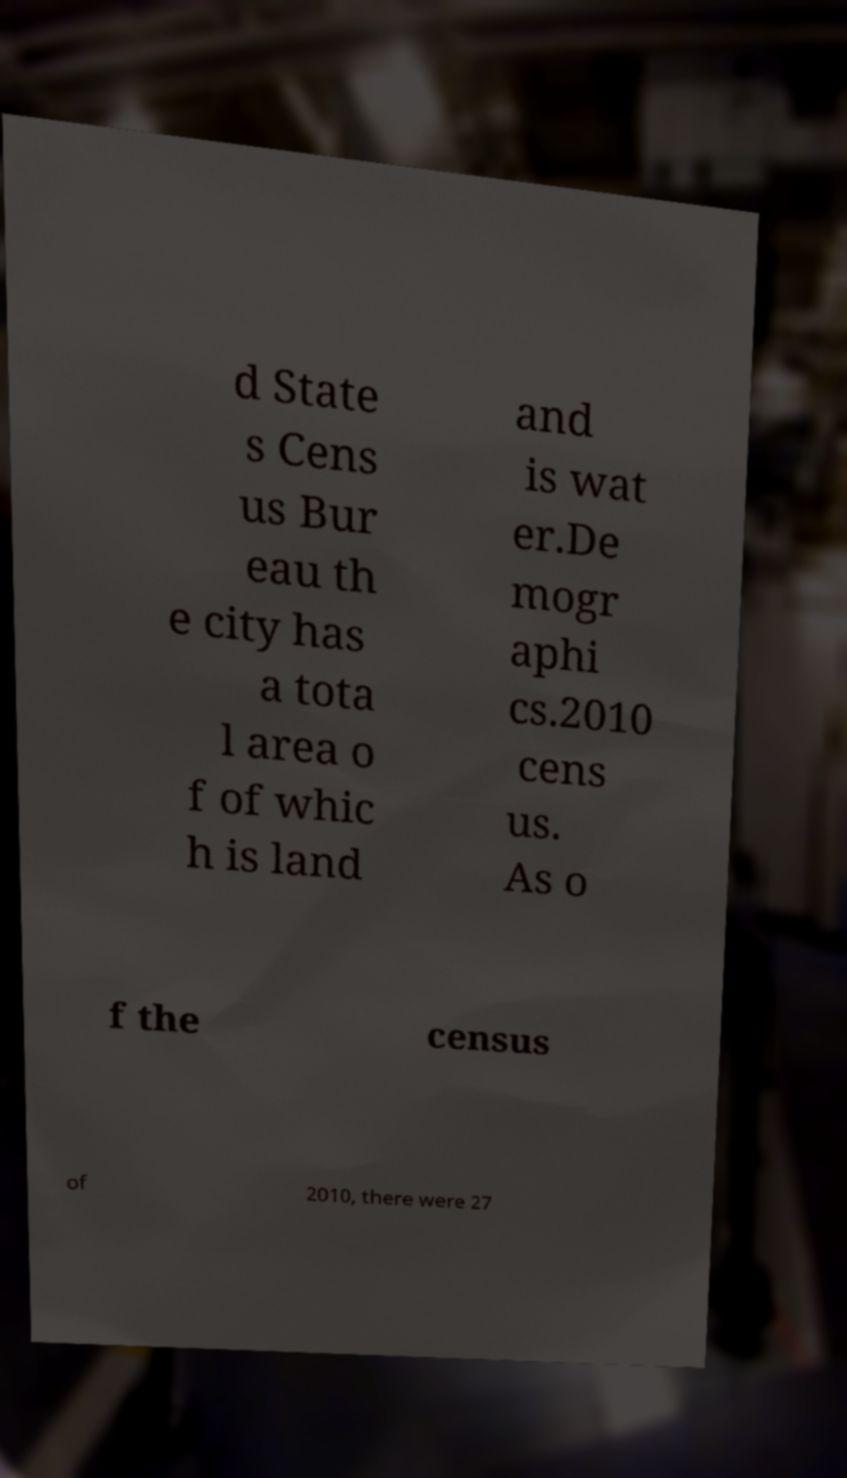Could you assist in decoding the text presented in this image and type it out clearly? d State s Cens us Bur eau th e city has a tota l area o f of whic h is land and is wat er.De mogr aphi cs.2010 cens us. As o f the census of 2010, there were 27 